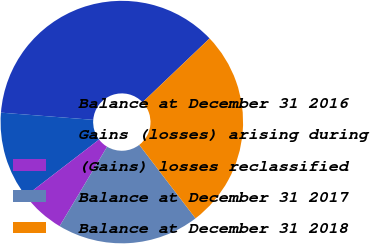Convert chart to OTSL. <chart><loc_0><loc_0><loc_500><loc_500><pie_chart><fcel>Balance at December 31 2016<fcel>Gains (losses) arising during<fcel>(Gains) losses reclassified<fcel>Balance at December 31 2017<fcel>Balance at December 31 2018<nl><fcel>36.64%<fcel>11.67%<fcel>6.0%<fcel>18.97%<fcel>26.72%<nl></chart> 